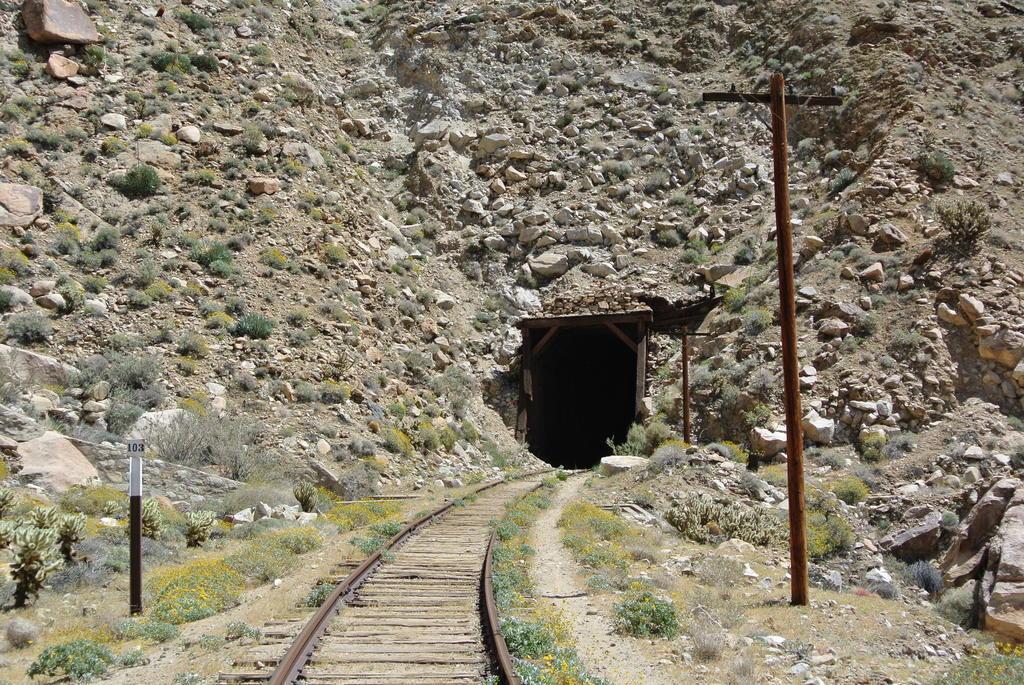Describe this image in one or two sentences. In the center of the image we can see a tunnel. At the bottom there is a railway track. On the right there is a pole. In the background there are rocks and we can see grass and shrubs. 